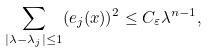<formula> <loc_0><loc_0><loc_500><loc_500>\sum _ { | \lambda - \lambda _ { j } | \leq 1 } ( e _ { j } ( x ) ) ^ { 2 } \leq C _ { \varepsilon } \lambda ^ { n - 1 } ,</formula> 